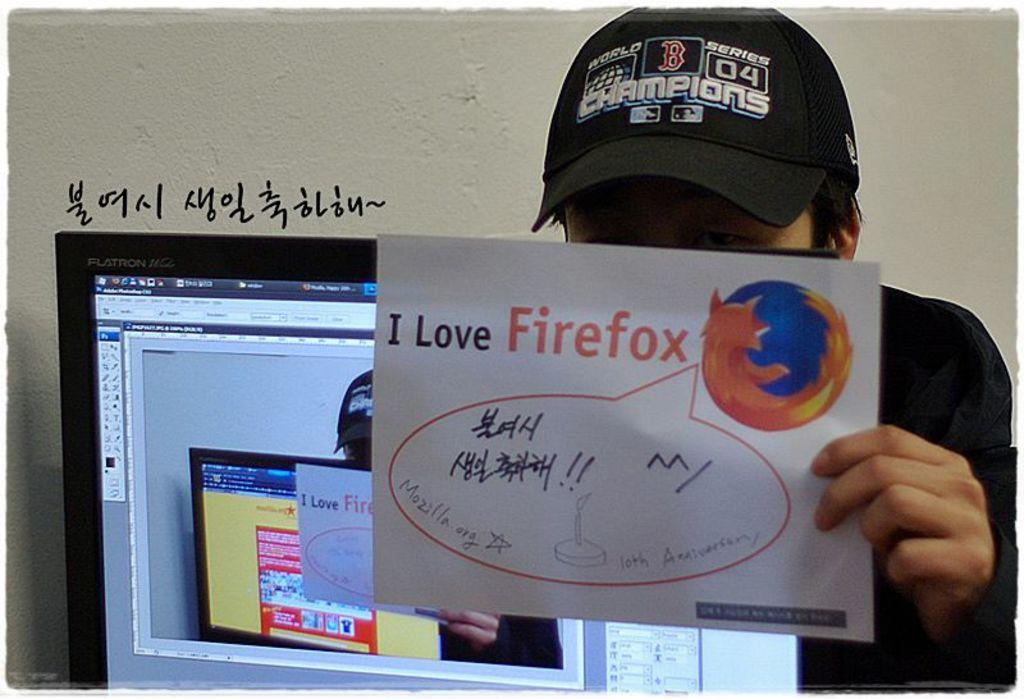What is the person in the image doing? The person is holding a paper with text. What object is beside the person in the image? There is a monitor beside the person. What can be seen on the wall in the background of the image? There is text on the wall. What is the overall setting of the image? The person is in a room with a wall in the background. Can you see any roses in the image? There are no roses present in the image. What type of waste is being disposed of in the image? There is no waste being disposed of in the image. 